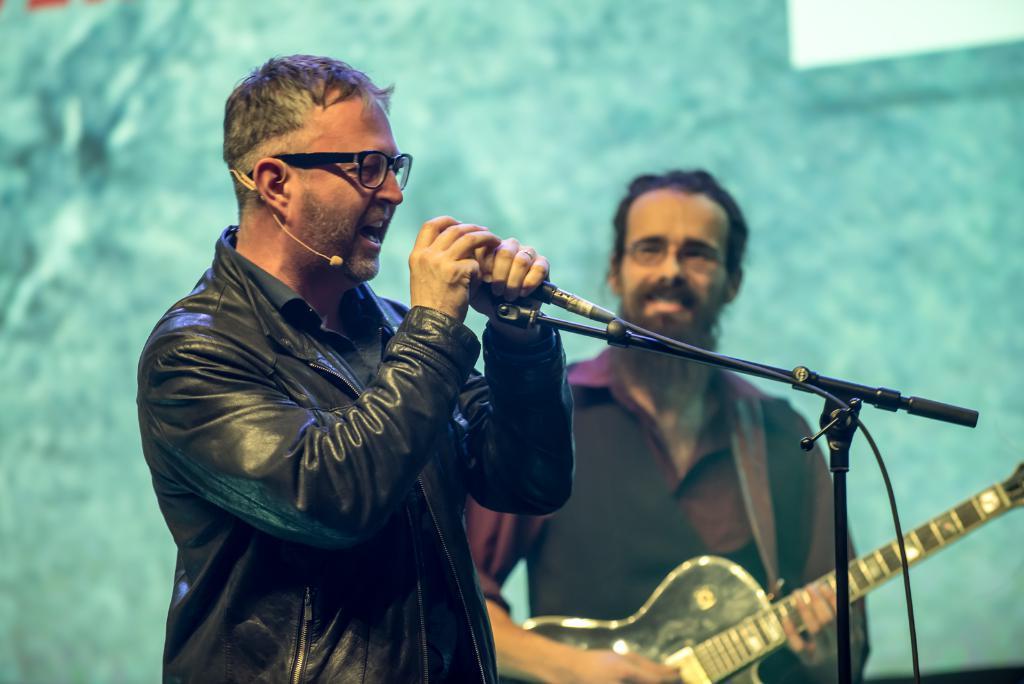Could you give a brief overview of what you see in this image? Two persons are standing holding microphone and a guitar. 